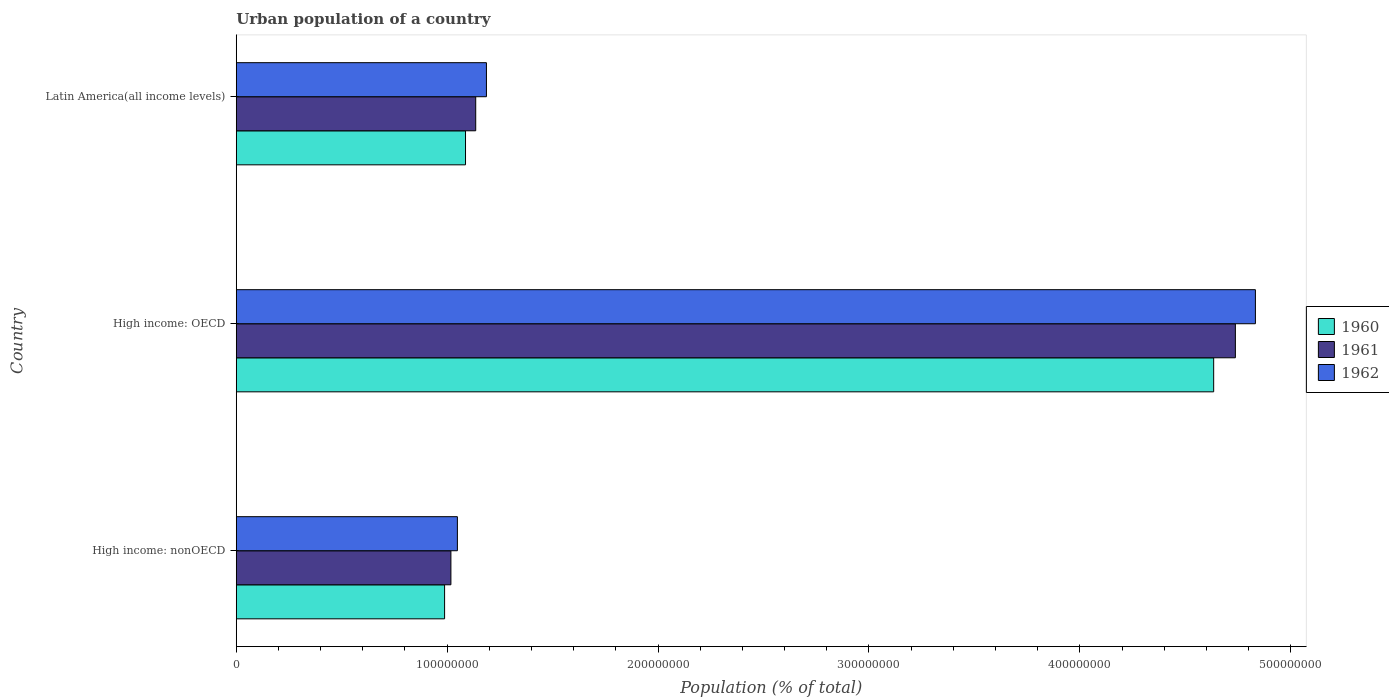How many different coloured bars are there?
Your response must be concise. 3. Are the number of bars on each tick of the Y-axis equal?
Your answer should be compact. Yes. How many bars are there on the 2nd tick from the top?
Keep it short and to the point. 3. What is the label of the 3rd group of bars from the top?
Give a very brief answer. High income: nonOECD. In how many cases, is the number of bars for a given country not equal to the number of legend labels?
Ensure brevity in your answer.  0. What is the urban population in 1961 in High income: OECD?
Provide a succinct answer. 4.74e+08. Across all countries, what is the maximum urban population in 1960?
Give a very brief answer. 4.63e+08. Across all countries, what is the minimum urban population in 1960?
Keep it short and to the point. 9.88e+07. In which country was the urban population in 1961 maximum?
Offer a very short reply. High income: OECD. In which country was the urban population in 1961 minimum?
Provide a short and direct response. High income: nonOECD. What is the total urban population in 1960 in the graph?
Your answer should be compact. 6.71e+08. What is the difference between the urban population in 1962 in High income: OECD and that in Latin America(all income levels)?
Make the answer very short. 3.65e+08. What is the difference between the urban population in 1962 in Latin America(all income levels) and the urban population in 1960 in High income: nonOECD?
Offer a very short reply. 1.98e+07. What is the average urban population in 1960 per country?
Your answer should be very brief. 2.24e+08. What is the difference between the urban population in 1961 and urban population in 1962 in High income: nonOECD?
Make the answer very short. -3.08e+06. In how many countries, is the urban population in 1962 greater than 320000000 %?
Provide a succinct answer. 1. What is the ratio of the urban population in 1961 in High income: nonOECD to that in Latin America(all income levels)?
Make the answer very short. 0.9. Is the difference between the urban population in 1961 in High income: OECD and High income: nonOECD greater than the difference between the urban population in 1962 in High income: OECD and High income: nonOECD?
Make the answer very short. No. What is the difference between the highest and the second highest urban population in 1962?
Offer a very short reply. 3.65e+08. What is the difference between the highest and the lowest urban population in 1960?
Ensure brevity in your answer.  3.65e+08. What does the 1st bar from the bottom in High income: OECD represents?
Ensure brevity in your answer.  1960. How many bars are there?
Offer a very short reply. 9. What is the difference between two consecutive major ticks on the X-axis?
Provide a succinct answer. 1.00e+08. Does the graph contain grids?
Your answer should be compact. No. How many legend labels are there?
Your response must be concise. 3. How are the legend labels stacked?
Keep it short and to the point. Vertical. What is the title of the graph?
Your answer should be very brief. Urban population of a country. What is the label or title of the X-axis?
Ensure brevity in your answer.  Population (% of total). What is the Population (% of total) of 1960 in High income: nonOECD?
Provide a succinct answer. 9.88e+07. What is the Population (% of total) of 1961 in High income: nonOECD?
Offer a very short reply. 1.02e+08. What is the Population (% of total) of 1962 in High income: nonOECD?
Your answer should be compact. 1.05e+08. What is the Population (% of total) of 1960 in High income: OECD?
Your answer should be compact. 4.63e+08. What is the Population (% of total) of 1961 in High income: OECD?
Offer a very short reply. 4.74e+08. What is the Population (% of total) of 1962 in High income: OECD?
Give a very brief answer. 4.83e+08. What is the Population (% of total) of 1960 in Latin America(all income levels)?
Make the answer very short. 1.09e+08. What is the Population (% of total) of 1961 in Latin America(all income levels)?
Your answer should be very brief. 1.14e+08. What is the Population (% of total) in 1962 in Latin America(all income levels)?
Keep it short and to the point. 1.19e+08. Across all countries, what is the maximum Population (% of total) of 1960?
Ensure brevity in your answer.  4.63e+08. Across all countries, what is the maximum Population (% of total) in 1961?
Provide a short and direct response. 4.74e+08. Across all countries, what is the maximum Population (% of total) of 1962?
Offer a very short reply. 4.83e+08. Across all countries, what is the minimum Population (% of total) in 1960?
Your response must be concise. 9.88e+07. Across all countries, what is the minimum Population (% of total) of 1961?
Offer a terse response. 1.02e+08. Across all countries, what is the minimum Population (% of total) in 1962?
Offer a very short reply. 1.05e+08. What is the total Population (% of total) of 1960 in the graph?
Your answer should be compact. 6.71e+08. What is the total Population (% of total) in 1961 in the graph?
Provide a short and direct response. 6.89e+08. What is the total Population (% of total) of 1962 in the graph?
Ensure brevity in your answer.  7.07e+08. What is the difference between the Population (% of total) in 1960 in High income: nonOECD and that in High income: OECD?
Keep it short and to the point. -3.65e+08. What is the difference between the Population (% of total) in 1961 in High income: nonOECD and that in High income: OECD?
Your answer should be very brief. -3.72e+08. What is the difference between the Population (% of total) in 1962 in High income: nonOECD and that in High income: OECD?
Your answer should be very brief. -3.78e+08. What is the difference between the Population (% of total) in 1960 in High income: nonOECD and that in Latin America(all income levels)?
Offer a very short reply. -9.92e+06. What is the difference between the Population (% of total) of 1961 in High income: nonOECD and that in Latin America(all income levels)?
Offer a terse response. -1.18e+07. What is the difference between the Population (% of total) in 1962 in High income: nonOECD and that in Latin America(all income levels)?
Provide a succinct answer. -1.38e+07. What is the difference between the Population (% of total) of 1960 in High income: OECD and that in Latin America(all income levels)?
Ensure brevity in your answer.  3.55e+08. What is the difference between the Population (% of total) in 1961 in High income: OECD and that in Latin America(all income levels)?
Provide a succinct answer. 3.60e+08. What is the difference between the Population (% of total) of 1962 in High income: OECD and that in Latin America(all income levels)?
Offer a terse response. 3.65e+08. What is the difference between the Population (% of total) in 1960 in High income: nonOECD and the Population (% of total) in 1961 in High income: OECD?
Make the answer very short. -3.75e+08. What is the difference between the Population (% of total) in 1960 in High income: nonOECD and the Population (% of total) in 1962 in High income: OECD?
Give a very brief answer. -3.84e+08. What is the difference between the Population (% of total) of 1961 in High income: nonOECD and the Population (% of total) of 1962 in High income: OECD?
Ensure brevity in your answer.  -3.81e+08. What is the difference between the Population (% of total) of 1960 in High income: nonOECD and the Population (% of total) of 1961 in Latin America(all income levels)?
Make the answer very short. -1.48e+07. What is the difference between the Population (% of total) of 1960 in High income: nonOECD and the Population (% of total) of 1962 in Latin America(all income levels)?
Offer a terse response. -1.98e+07. What is the difference between the Population (% of total) in 1961 in High income: nonOECD and the Population (% of total) in 1962 in Latin America(all income levels)?
Your answer should be compact. -1.68e+07. What is the difference between the Population (% of total) in 1960 in High income: OECD and the Population (% of total) in 1961 in Latin America(all income levels)?
Keep it short and to the point. 3.50e+08. What is the difference between the Population (% of total) in 1960 in High income: OECD and the Population (% of total) in 1962 in Latin America(all income levels)?
Provide a succinct answer. 3.45e+08. What is the difference between the Population (% of total) of 1961 in High income: OECD and the Population (% of total) of 1962 in Latin America(all income levels)?
Your answer should be very brief. 3.55e+08. What is the average Population (% of total) in 1960 per country?
Your answer should be compact. 2.24e+08. What is the average Population (% of total) of 1961 per country?
Offer a very short reply. 2.30e+08. What is the average Population (% of total) in 1962 per country?
Your answer should be compact. 2.36e+08. What is the difference between the Population (% of total) of 1960 and Population (% of total) of 1961 in High income: nonOECD?
Provide a succinct answer. -2.99e+06. What is the difference between the Population (% of total) in 1960 and Population (% of total) in 1962 in High income: nonOECD?
Offer a very short reply. -6.07e+06. What is the difference between the Population (% of total) of 1961 and Population (% of total) of 1962 in High income: nonOECD?
Ensure brevity in your answer.  -3.08e+06. What is the difference between the Population (% of total) of 1960 and Population (% of total) of 1961 in High income: OECD?
Keep it short and to the point. -1.03e+07. What is the difference between the Population (% of total) in 1960 and Population (% of total) in 1962 in High income: OECD?
Keep it short and to the point. -1.98e+07. What is the difference between the Population (% of total) of 1961 and Population (% of total) of 1962 in High income: OECD?
Your answer should be very brief. -9.50e+06. What is the difference between the Population (% of total) of 1960 and Population (% of total) of 1961 in Latin America(all income levels)?
Your answer should be compact. -4.84e+06. What is the difference between the Population (% of total) of 1960 and Population (% of total) of 1962 in Latin America(all income levels)?
Make the answer very short. -9.92e+06. What is the difference between the Population (% of total) in 1961 and Population (% of total) in 1962 in Latin America(all income levels)?
Your answer should be compact. -5.08e+06. What is the ratio of the Population (% of total) of 1960 in High income: nonOECD to that in High income: OECD?
Your response must be concise. 0.21. What is the ratio of the Population (% of total) in 1961 in High income: nonOECD to that in High income: OECD?
Keep it short and to the point. 0.21. What is the ratio of the Population (% of total) of 1962 in High income: nonOECD to that in High income: OECD?
Offer a terse response. 0.22. What is the ratio of the Population (% of total) of 1960 in High income: nonOECD to that in Latin America(all income levels)?
Ensure brevity in your answer.  0.91. What is the ratio of the Population (% of total) of 1961 in High income: nonOECD to that in Latin America(all income levels)?
Ensure brevity in your answer.  0.9. What is the ratio of the Population (% of total) in 1962 in High income: nonOECD to that in Latin America(all income levels)?
Offer a very short reply. 0.88. What is the ratio of the Population (% of total) of 1960 in High income: OECD to that in Latin America(all income levels)?
Your answer should be very brief. 4.26. What is the ratio of the Population (% of total) of 1961 in High income: OECD to that in Latin America(all income levels)?
Offer a very short reply. 4.17. What is the ratio of the Population (% of total) in 1962 in High income: OECD to that in Latin America(all income levels)?
Provide a succinct answer. 4.07. What is the difference between the highest and the second highest Population (% of total) of 1960?
Make the answer very short. 3.55e+08. What is the difference between the highest and the second highest Population (% of total) of 1961?
Provide a succinct answer. 3.60e+08. What is the difference between the highest and the second highest Population (% of total) of 1962?
Provide a succinct answer. 3.65e+08. What is the difference between the highest and the lowest Population (% of total) of 1960?
Offer a terse response. 3.65e+08. What is the difference between the highest and the lowest Population (% of total) of 1961?
Give a very brief answer. 3.72e+08. What is the difference between the highest and the lowest Population (% of total) of 1962?
Make the answer very short. 3.78e+08. 